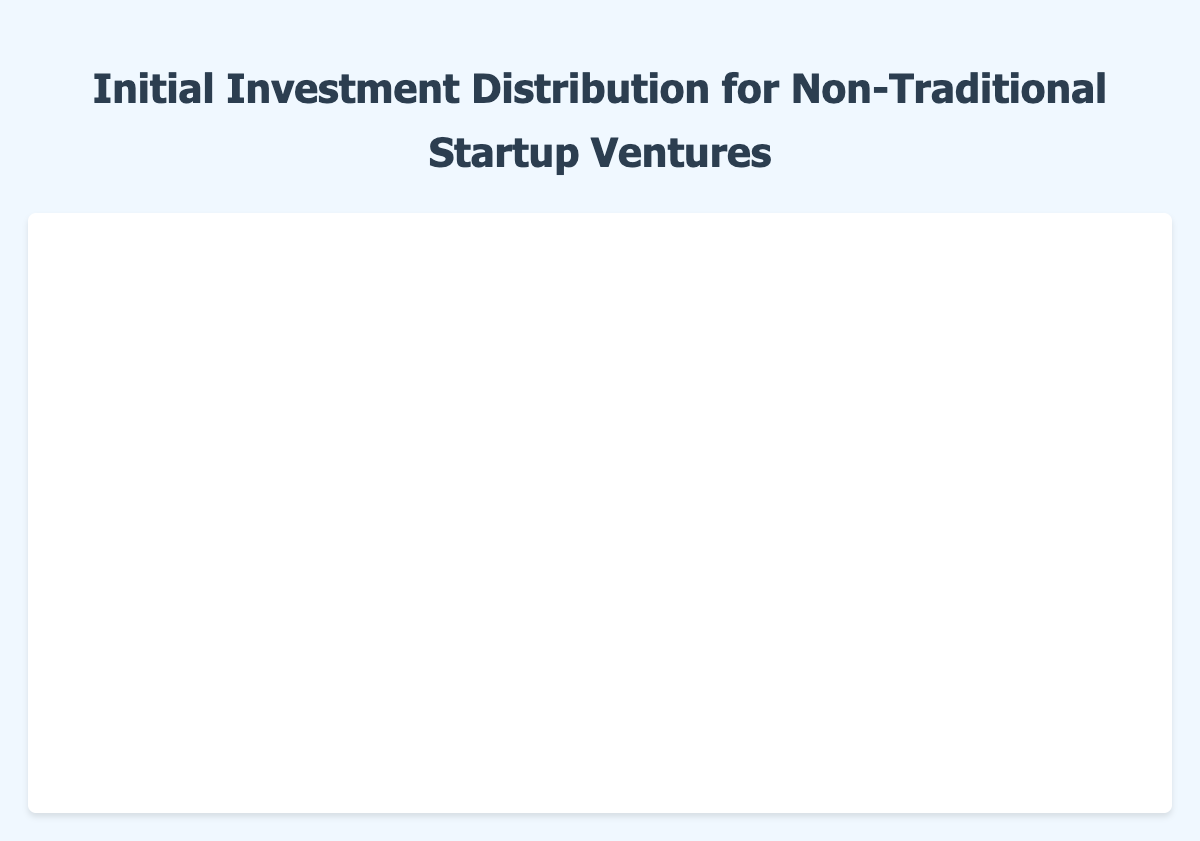What is the title of the plot? The title of the plot is displayed at the top of the figure. It reads "Initial Investment Distribution for Non-Traditional Startup Ventures".
Answer: Initial Investment Distribution for Non-Traditional Startup Ventures Which type of startup requires the highest median initial investment? The median is represented by the line inside each box. Comparing the medians for all the startup types, the "Tech Startup" has the highest median.
Answer: Tech Startup What is the median initial investment for an Artisanal Crafts Business? The median value is indicated by the line inside the Artisanal Crafts Business box. It is approximately $7500.
Answer: $7500 Which startup type has the widest range of initial investment values? The range is calculated by finding the difference between the maximum and minimum values (the whiskers) for each startup type. The "Tech Startup" has the widest range, spanning from $25000 to $60000.
Answer: Tech Startup Between a Sustainable Fashion Brand and an Online Education Platform, which one requires a higher minimum investment? The minimum investment for a Sustainable Fashion Brand can be seen at the lower whisker of its box plot, which is $15000. For an Online Education Platform, it's $29000. Comparing these values, the Online Education Platform has a higher minimum investment.
Answer: Online Education Platform What is the range of initial investment for a Freelance Consulting Firm? The range is the difference between the maximum and minimum values. For a Freelance Consulting Firm, the maximum is $6000 and the minimum is $2000, so the range is $6000 - $2000 = $4000.
Answer: $4000 Which startup type has the lowest median initial investment? The median for each type is marked by the line inside the box. The "Freelance Consulting Firm" has the lowest median compared with others, approximately $3500.
Answer: Freelance Consulting Firm How does the variability of initial investment for Health and Wellness Services compare to Tech Startups? The variability can be assessed by the interquartile range (IQR), which is the length of the box. The IQR for Health and Wellness Services is smaller than that for Tech Startups, indicating less variability in initial investments.
Answer: Smaller for Health and Wellness Services What are the outliers present in the initial investment distribution? Outliers are displayed as individual points outside the whiskers. Since no individual points are visible outside the whiskers in any of the box plots, there are no outliers.
Answer: No outliers What is the upper quartile value for an Online Education Platform? The upper quartile value is the top edge of the box. For an Online Education Platform, it's approximately $37000.
Answer: $37000 